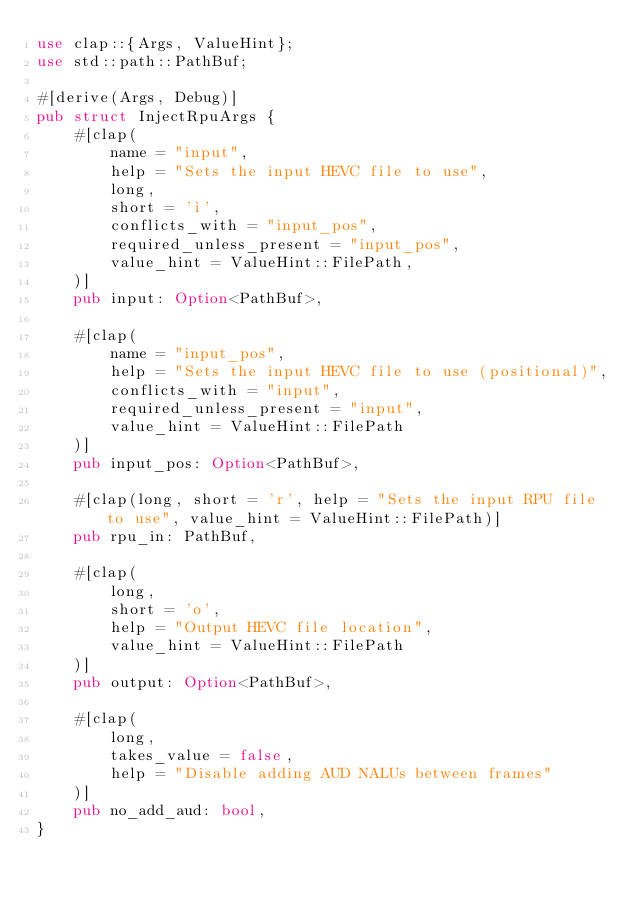Convert code to text. <code><loc_0><loc_0><loc_500><loc_500><_Rust_>use clap::{Args, ValueHint};
use std::path::PathBuf;

#[derive(Args, Debug)]
pub struct InjectRpuArgs {
    #[clap(
        name = "input",
        help = "Sets the input HEVC file to use",
        long,
        short = 'i',
        conflicts_with = "input_pos",
        required_unless_present = "input_pos",
        value_hint = ValueHint::FilePath,
    )]
    pub input: Option<PathBuf>,

    #[clap(
        name = "input_pos",
        help = "Sets the input HEVC file to use (positional)",
        conflicts_with = "input",
        required_unless_present = "input",
        value_hint = ValueHint::FilePath
    )]
    pub input_pos: Option<PathBuf>,

    #[clap(long, short = 'r', help = "Sets the input RPU file to use", value_hint = ValueHint::FilePath)]
    pub rpu_in: PathBuf,

    #[clap(
        long,
        short = 'o',
        help = "Output HEVC file location",
        value_hint = ValueHint::FilePath
    )]
    pub output: Option<PathBuf>,

    #[clap(
        long,
        takes_value = false,
        help = "Disable adding AUD NALUs between frames"
    )]
    pub no_add_aud: bool,
}
</code> 